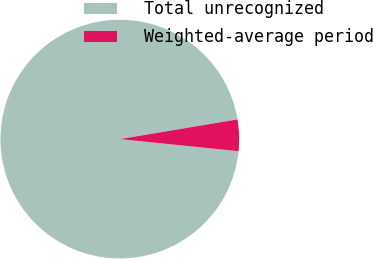<chart> <loc_0><loc_0><loc_500><loc_500><pie_chart><fcel>Total unrecognized<fcel>Weighted-average period<nl><fcel>95.74%<fcel>4.26%<nl></chart> 